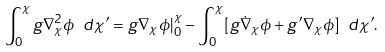Convert formula to latex. <formula><loc_0><loc_0><loc_500><loc_500>\int _ { 0 } ^ { \chi } g \nabla _ { \chi } ^ { 2 } \phi \ d \chi ^ { \prime } = g \nabla _ { \chi } \phi | _ { 0 } ^ { \chi } - \int _ { 0 } ^ { \chi } [ g \dot { \nabla } _ { \chi } \phi + g ^ { \prime } \nabla _ { \chi } \phi ] \ d \chi ^ { \prime } .</formula> 